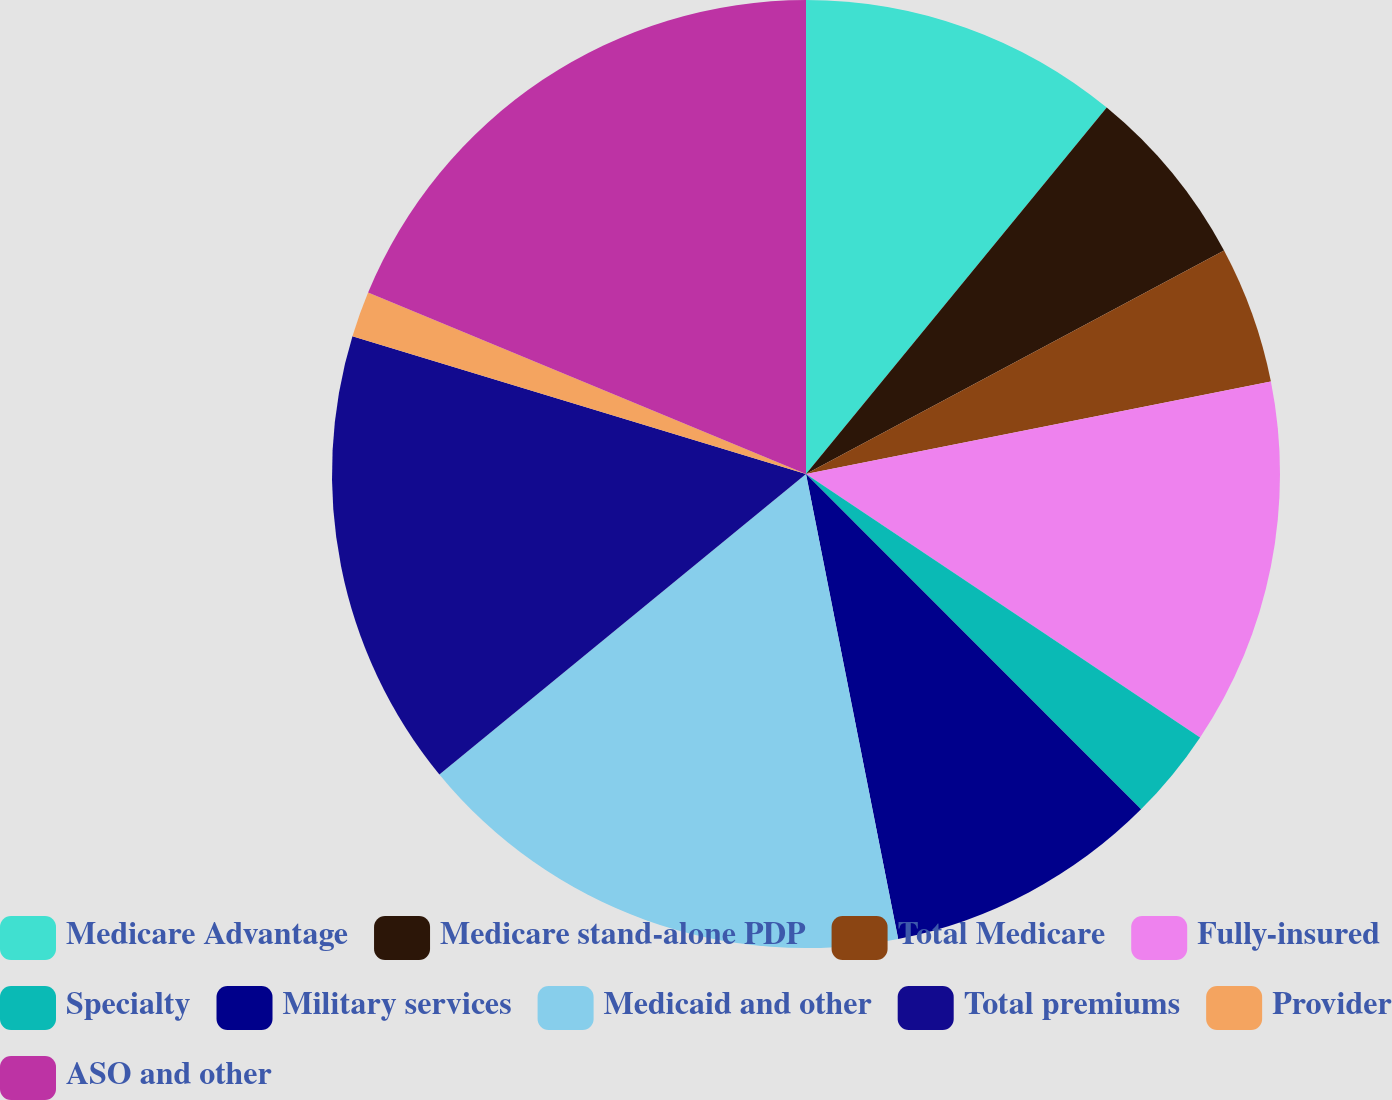<chart> <loc_0><loc_0><loc_500><loc_500><pie_chart><fcel>Medicare Advantage<fcel>Medicare stand-alone PDP<fcel>Total Medicare<fcel>Fully-insured<fcel>Specialty<fcel>Military services<fcel>Medicaid and other<fcel>Total premiums<fcel>Provider<fcel>ASO and other<nl><fcel>10.94%<fcel>6.25%<fcel>4.69%<fcel>12.5%<fcel>3.13%<fcel>9.38%<fcel>17.19%<fcel>15.62%<fcel>1.56%<fcel>18.75%<nl></chart> 